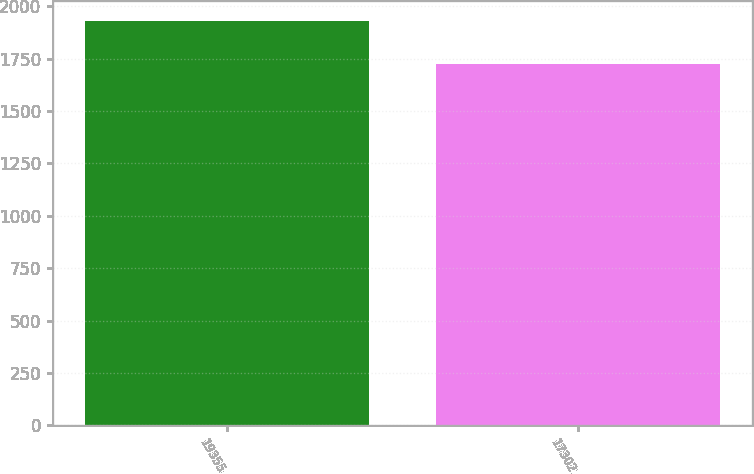<chart> <loc_0><loc_0><loc_500><loc_500><bar_chart><fcel>19355<fcel>17302<nl><fcel>1930.6<fcel>1726.4<nl></chart> 